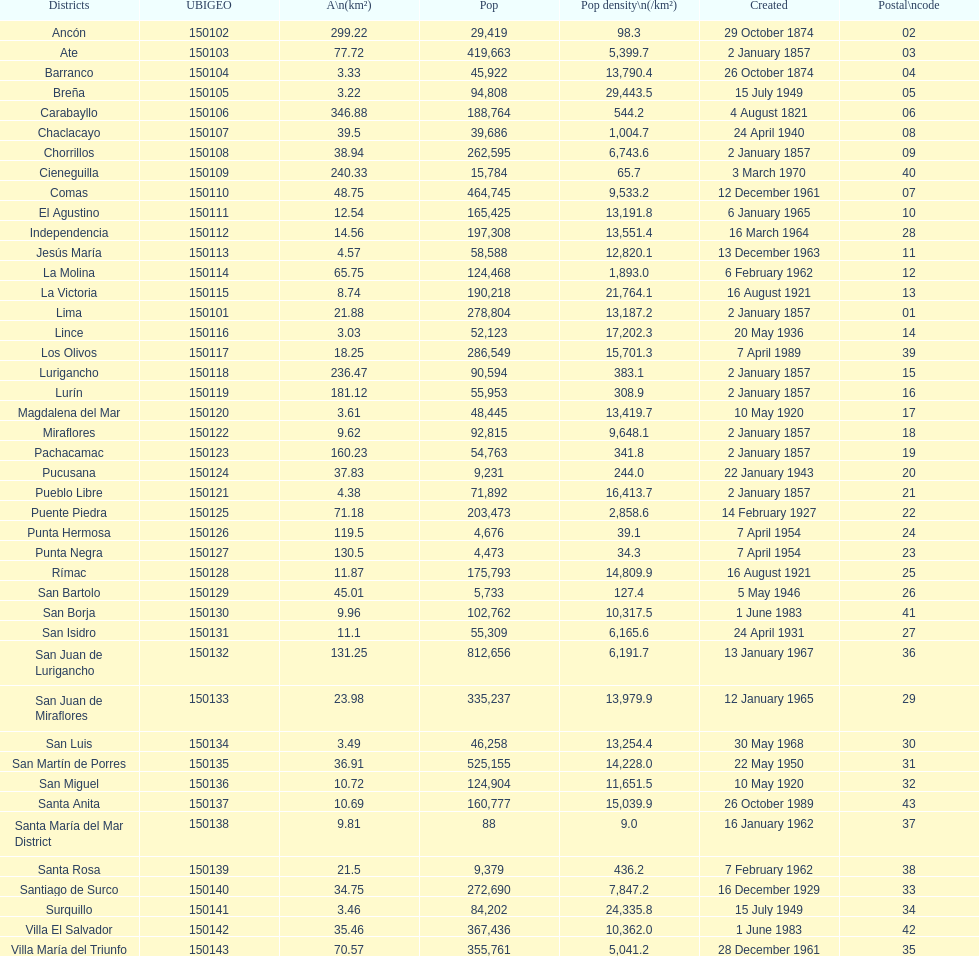What is the total number of districts of lima? 43. 